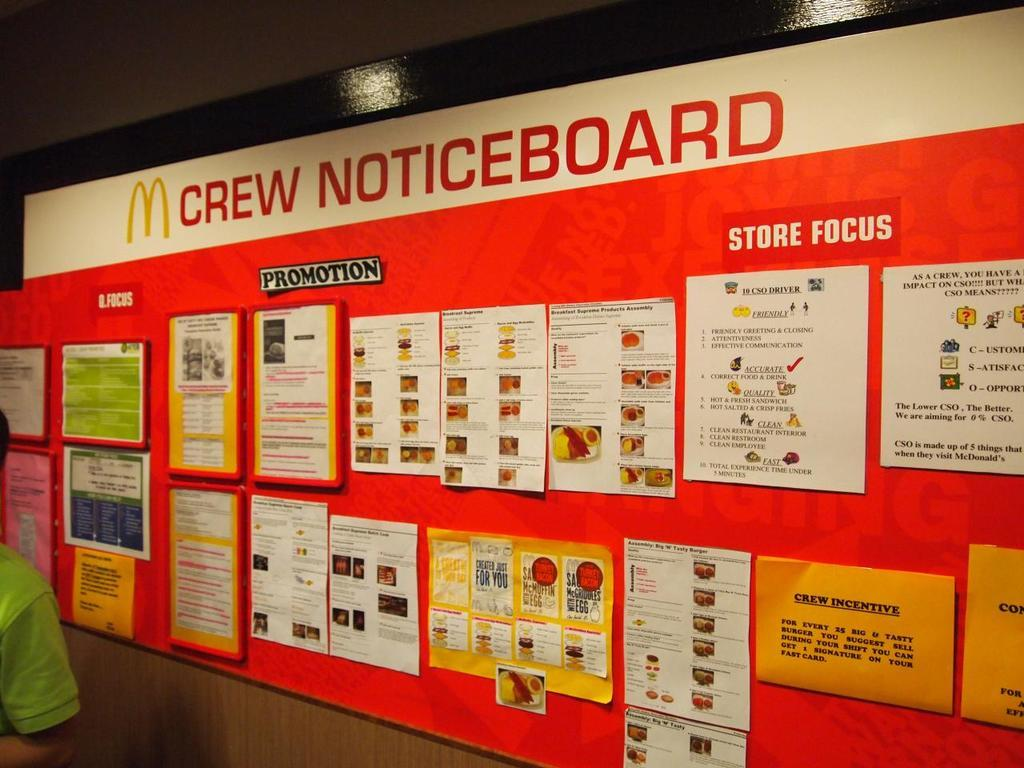What is the main object in the image? There is a notice board in the image. What is attached to the notice board? The notice board has posters and papers attached. Can you describe the person in the image? There is a person on the left side of the image. What is located at the top of the image? The image includes a well at the top. What position does the person need to maintain to balance the copy on their head? There is no person balancing a copy on their head in the image. 